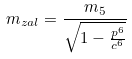<formula> <loc_0><loc_0><loc_500><loc_500>m _ { z a l } = \frac { m _ { 5 } } { \sqrt { 1 - \frac { p ^ { 6 } } { c ^ { 6 } } } }</formula> 